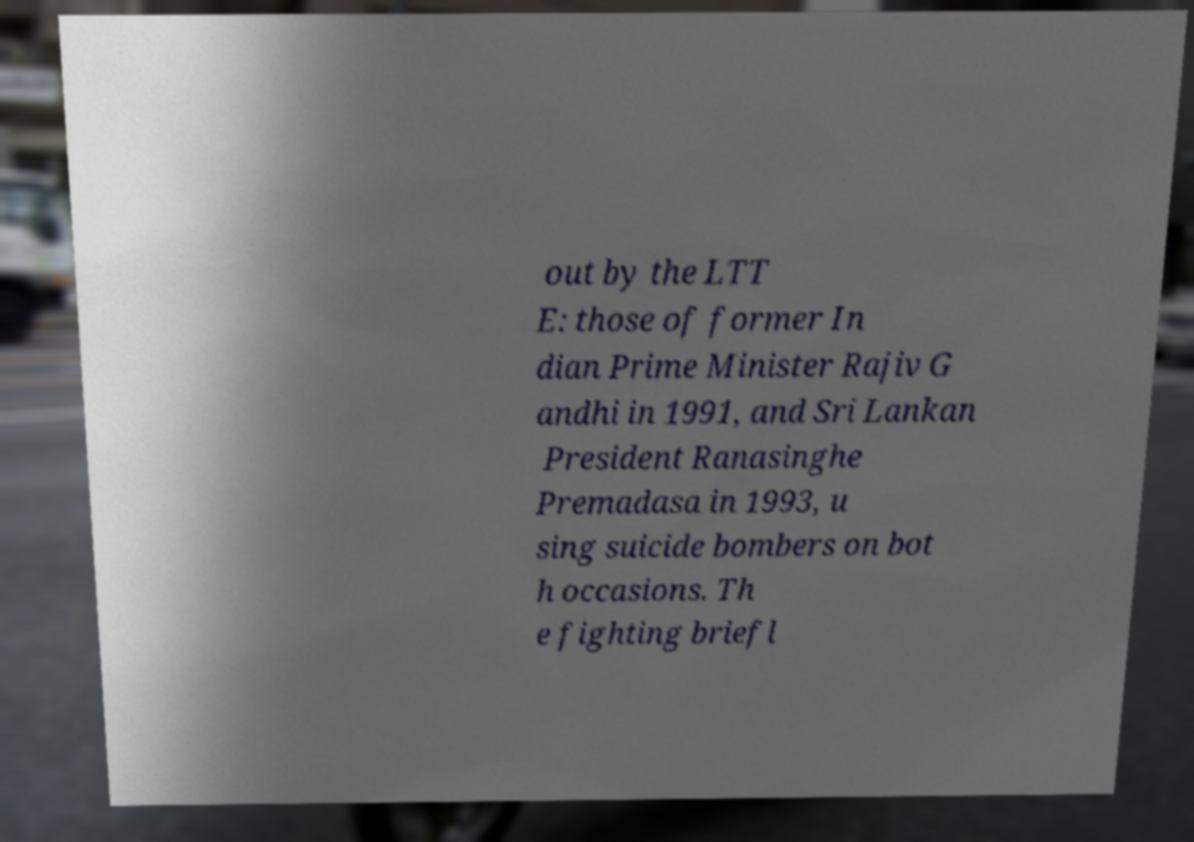What messages or text are displayed in this image? I need them in a readable, typed format. out by the LTT E: those of former In dian Prime Minister Rajiv G andhi in 1991, and Sri Lankan President Ranasinghe Premadasa in 1993, u sing suicide bombers on bot h occasions. Th e fighting briefl 